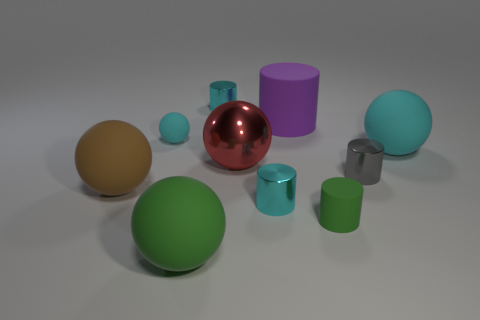What can you infer about the material of the blue ball? The blue ball has a matte finish with a soft sheen, suggesting it might be made of a material like rubber or a non-reflective plastic. Its surface doesn't reflect the environment sharply, which means it's not metallic or highly polished. How do you think the textures of the objects contribute to the overall aesthetics of the image? The varied textures in the image create a visually engaging contrast. The matte surfaces of objects like the blue ball and the purple cylinder offer a soothing visual effect, while the reflective surfaces of the red and teal objects draw the eye with their bright highlights. These contrasting textures complement each other and add depth, making the image more interesting and aesthetically pleasing. 